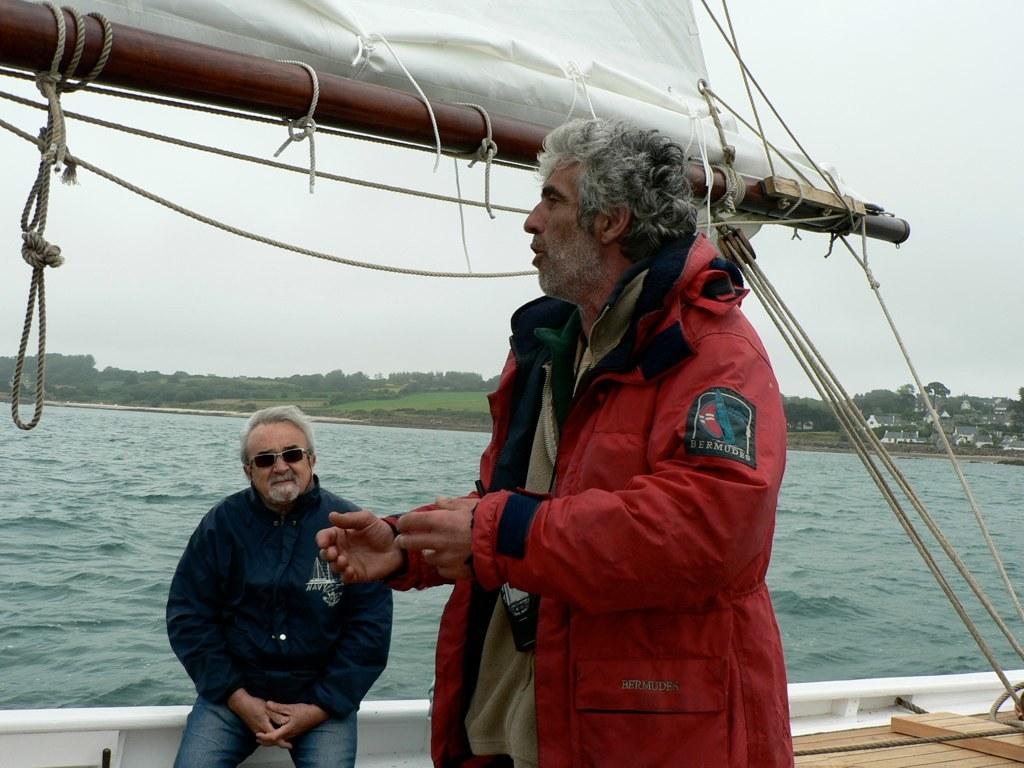What's on the person's patch on the jacket?
Give a very brief answer. Bermudes. 